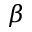<formula> <loc_0><loc_0><loc_500><loc_500>\beta</formula> 